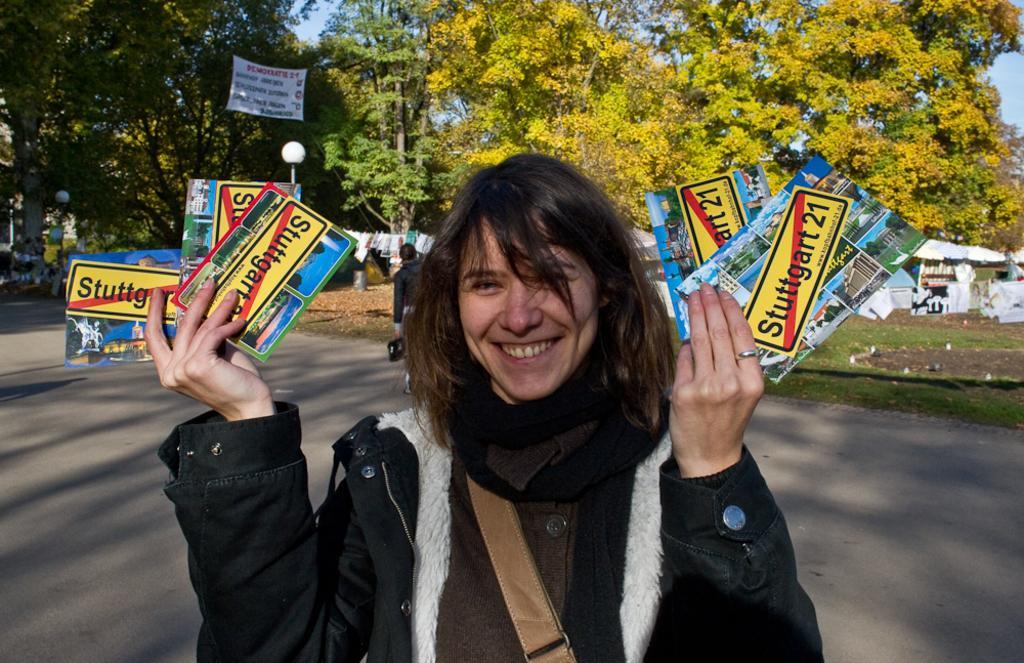Can you describe this image briefly? In this image we can see a woman smiling and holding the cards. In the background we can see the trees, light poles, grass and also the sky. We can also see a person holding an object. We can see the road and also the clothes. 